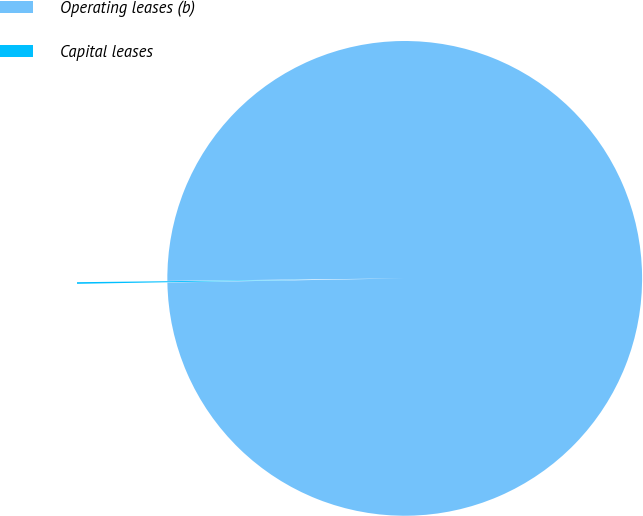Convert chart. <chart><loc_0><loc_0><loc_500><loc_500><pie_chart><fcel>Operating leases (b)<fcel>Capital leases<nl><fcel>99.89%<fcel>0.11%<nl></chart> 